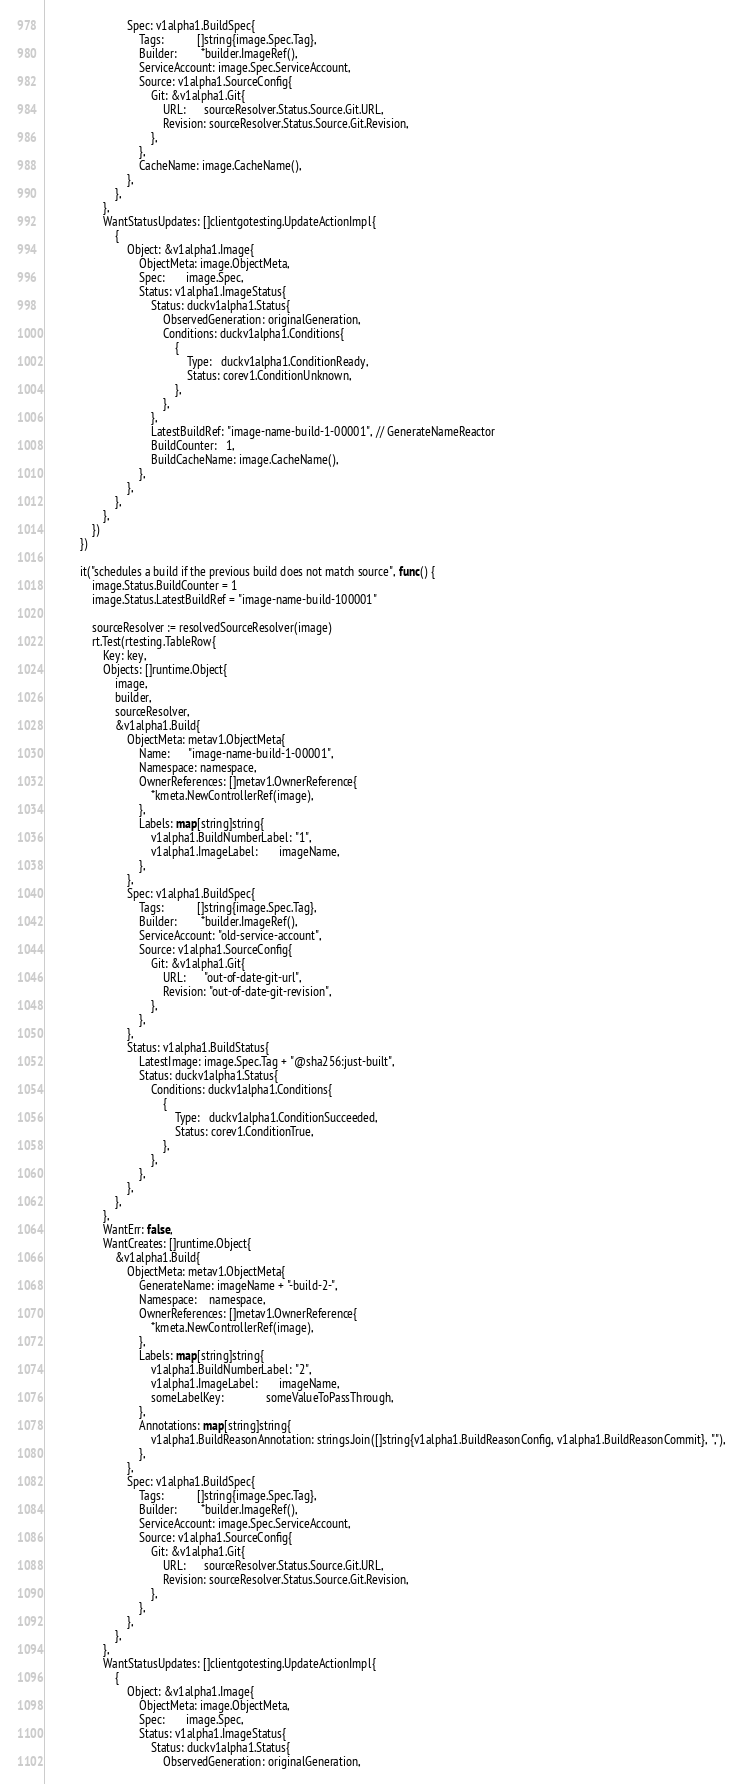Convert code to text. <code><loc_0><loc_0><loc_500><loc_500><_Go_>							Spec: v1alpha1.BuildSpec{
								Tags:           []string{image.Spec.Tag},
								Builder:        *builder.ImageRef(),
								ServiceAccount: image.Spec.ServiceAccount,
								Source: v1alpha1.SourceConfig{
									Git: &v1alpha1.Git{
										URL:      sourceResolver.Status.Source.Git.URL,
										Revision: sourceResolver.Status.Source.Git.Revision,
									},
								},
								CacheName: image.CacheName(),
							},
						},
					},
					WantStatusUpdates: []clientgotesting.UpdateActionImpl{
						{
							Object: &v1alpha1.Image{
								ObjectMeta: image.ObjectMeta,
								Spec:       image.Spec,
								Status: v1alpha1.ImageStatus{
									Status: duckv1alpha1.Status{
										ObservedGeneration: originalGeneration,
										Conditions: duckv1alpha1.Conditions{
											{
												Type:   duckv1alpha1.ConditionReady,
												Status: corev1.ConditionUnknown,
											},
										},
									},
									LatestBuildRef: "image-name-build-1-00001", // GenerateNameReactor
									BuildCounter:   1,
									BuildCacheName: image.CacheName(),
								},
							},
						},
					},
				})
			})

			it("schedules a build if the previous build does not match source", func() {
				image.Status.BuildCounter = 1
				image.Status.LatestBuildRef = "image-name-build-100001"

				sourceResolver := resolvedSourceResolver(image)
				rt.Test(rtesting.TableRow{
					Key: key,
					Objects: []runtime.Object{
						image,
						builder,
						sourceResolver,
						&v1alpha1.Build{
							ObjectMeta: metav1.ObjectMeta{
								Name:      "image-name-build-1-00001",
								Namespace: namespace,
								OwnerReferences: []metav1.OwnerReference{
									*kmeta.NewControllerRef(image),
								},
								Labels: map[string]string{
									v1alpha1.BuildNumberLabel: "1",
									v1alpha1.ImageLabel:       imageName,
								},
							},
							Spec: v1alpha1.BuildSpec{
								Tags:           []string{image.Spec.Tag},
								Builder:        *builder.ImageRef(),
								ServiceAccount: "old-service-account",
								Source: v1alpha1.SourceConfig{
									Git: &v1alpha1.Git{
										URL:      "out-of-date-git-url",
										Revision: "out-of-date-git-revision",
									},
								},
							},
							Status: v1alpha1.BuildStatus{
								LatestImage: image.Spec.Tag + "@sha256:just-built",
								Status: duckv1alpha1.Status{
									Conditions: duckv1alpha1.Conditions{
										{
											Type:   duckv1alpha1.ConditionSucceeded,
											Status: corev1.ConditionTrue,
										},
									},
								},
							},
						},
					},
					WantErr: false,
					WantCreates: []runtime.Object{
						&v1alpha1.Build{
							ObjectMeta: metav1.ObjectMeta{
								GenerateName: imageName + "-build-2-",
								Namespace:    namespace,
								OwnerReferences: []metav1.OwnerReference{
									*kmeta.NewControllerRef(image),
								},
								Labels: map[string]string{
									v1alpha1.BuildNumberLabel: "2",
									v1alpha1.ImageLabel:       imageName,
									someLabelKey:              someValueToPassThrough,
								},
								Annotations: map[string]string{
									v1alpha1.BuildReasonAnnotation: strings.Join([]string{v1alpha1.BuildReasonConfig, v1alpha1.BuildReasonCommit}, ","),
								},
							},
							Spec: v1alpha1.BuildSpec{
								Tags:           []string{image.Spec.Tag},
								Builder:        *builder.ImageRef(),
								ServiceAccount: image.Spec.ServiceAccount,
								Source: v1alpha1.SourceConfig{
									Git: &v1alpha1.Git{
										URL:      sourceResolver.Status.Source.Git.URL,
										Revision: sourceResolver.Status.Source.Git.Revision,
									},
								},
							},
						},
					},
					WantStatusUpdates: []clientgotesting.UpdateActionImpl{
						{
							Object: &v1alpha1.Image{
								ObjectMeta: image.ObjectMeta,
								Spec:       image.Spec,
								Status: v1alpha1.ImageStatus{
									Status: duckv1alpha1.Status{
										ObservedGeneration: originalGeneration,</code> 